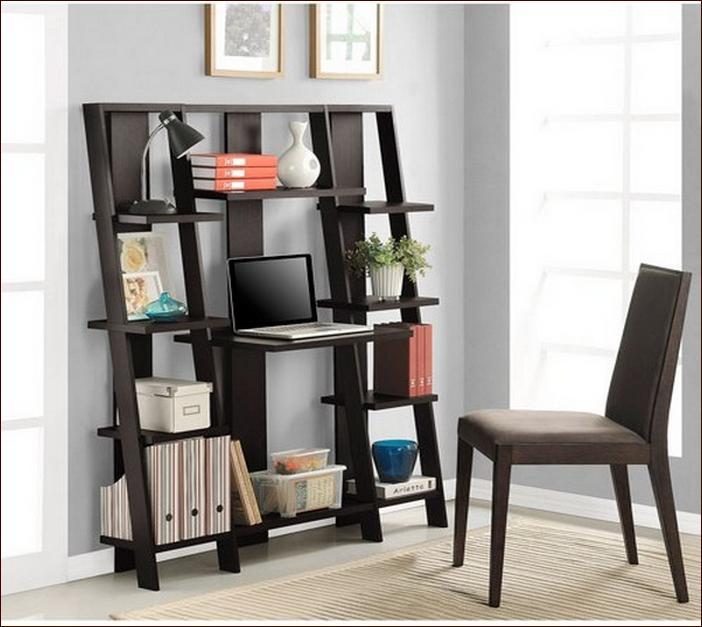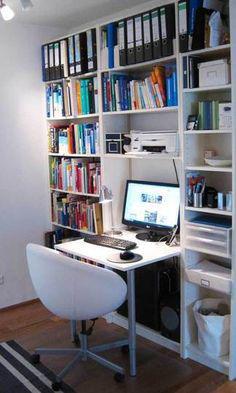The first image is the image on the left, the second image is the image on the right. Evaluate the accuracy of this statement regarding the images: "In one of the photos, there is a potted plant sitting on a shelf.". Is it true? Answer yes or no. Yes. The first image is the image on the left, the second image is the image on the right. Evaluate the accuracy of this statement regarding the images: "there is a built in desk and wall shelves with a desk chair at the desk". Is it true? Answer yes or no. Yes. 